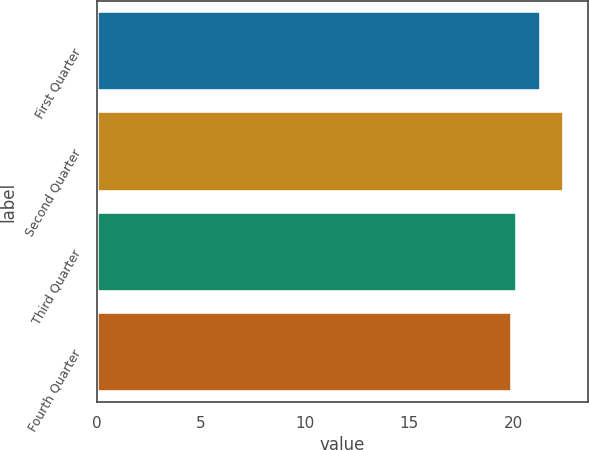<chart> <loc_0><loc_0><loc_500><loc_500><bar_chart><fcel>First Quarter<fcel>Second Quarter<fcel>Third Quarter<fcel>Fourth Quarter<nl><fcel>21.32<fcel>22.44<fcel>20.18<fcel>19.93<nl></chart> 